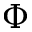Convert formula to latex. <formula><loc_0><loc_0><loc_500><loc_500>\Phi</formula> 